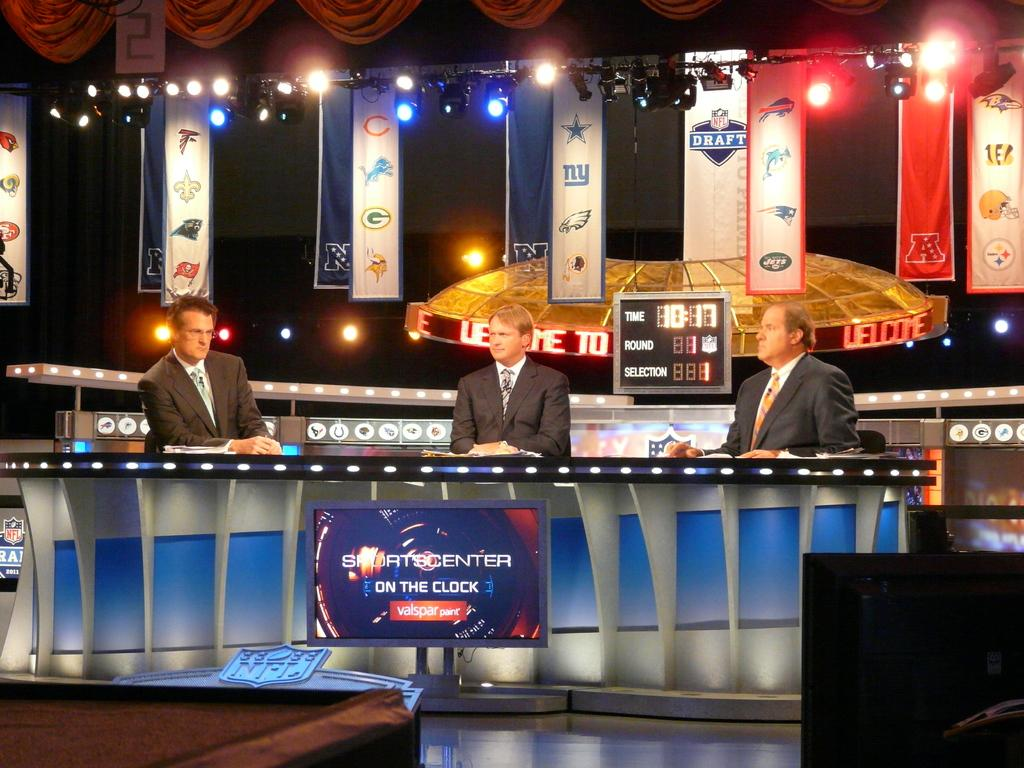How many people are sitting in the chairs in the image? There are three persons sitting on chairs in the image. What can be seen on the screen in the image? The facts do not specify what is on the screen, so we cannot answer that question definitively. What is the purpose of the table in the image? The facts do not specify the purpose of the table, so we cannot answer that question definitively. What is present in the background of the image? Banners and lights are visible in the background of the image. What type of ice can be seen in the vase on the table in the image? There is no vase or ice present in the image. What type of market is depicted in the image? There is no market depicted in the image. 